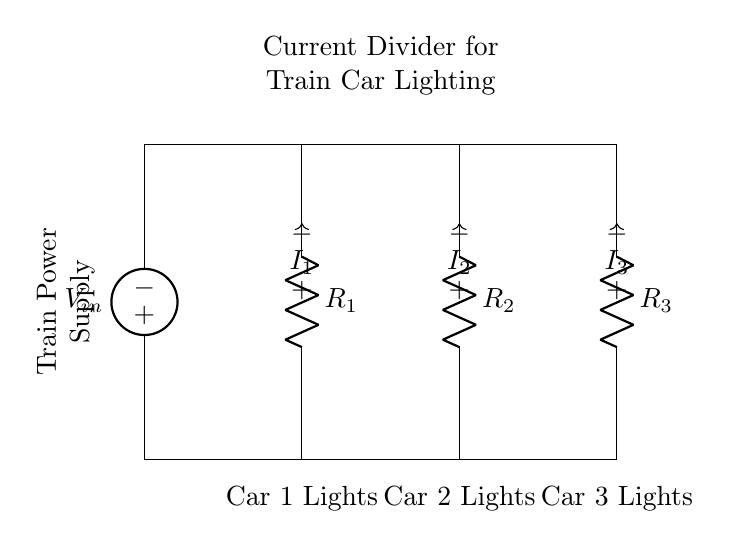What is the voltage source in this circuit? The voltage source is indicated at the top of the diagram labeled as V_in. It provides the input voltage to the entire current divider network.
Answer: V_in What are the resistances in the circuit? The circuit contains three resistors labeled R_1, R_2, and R_3. These resistors are part of the current divider and serve to divide the input current among the load lights.
Answer: R_1, R_2, R_3 What current flows through R_2? The current flowing through R_2 is labeled as I_2, which is shown in the diagram as one of the currents being distributed from the power supply.
Answer: I_2 Which components feed the lighting systems in the train cars? The components feeding the lighting systems are the three resistors (R_1, R_2, R_3) connected to the respective train car lights. Each resistor is connected to the lights of a different car.
Answer: R_1 for Car 1, R_2 for Car 2, R_3 for Car 3 How is the current divided in this circuit? The current is divided according to the resistance values of R_1, R_2, and R_3. According to the current divider principle, a larger resistance will have less current flowing through it compared to a smaller resistance. Thus I_1, I_2, and I_3 will vary based on the values of R_1, R_2, and R_3.
Answer: According to resistance values What is the purpose of this current divider network? The purpose is to ensure that power is distributed among multiple lighting systems in train cars evenly, while allowing for different current levels based on the resistance of each branch.
Answer: Distributing power to train car lighting 